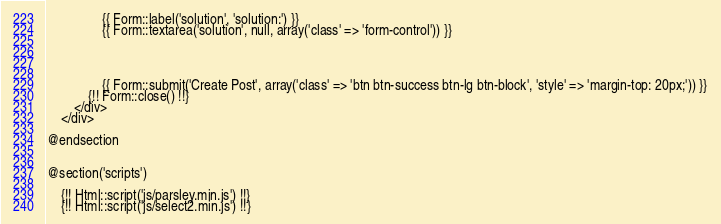<code> <loc_0><loc_0><loc_500><loc_500><_PHP_>
				{{ Form::label('solution', 'solution:') }}
                {{ Form::textarea('solution', null, array('class' => 'form-control')) }}




				{{ Form::submit('Create Post', array('class' => 'btn btn-success btn-lg btn-block', 'style' => 'margin-top: 20px;')) }}
			{!! Form::close() !!}
		</div>
	</div>

@endsection


@section('scripts')

	{!! Html::script('js/parsley.min.js') !!}
	{!! Html::script('js/select2.min.js') !!}
</code> 